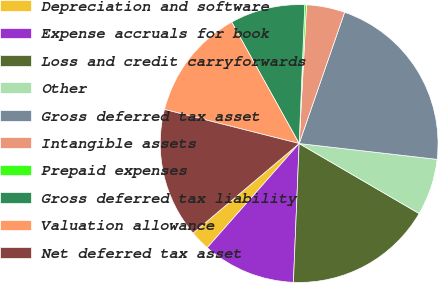Convert chart to OTSL. <chart><loc_0><loc_0><loc_500><loc_500><pie_chart><fcel>Depreciation and software<fcel>Expense accruals for book<fcel>Loss and credit carryforwards<fcel>Other<fcel>Gross deferred tax asset<fcel>Intangible assets<fcel>Prepaid expenses<fcel>Gross deferred tax liability<fcel>Valuation allowance<fcel>Net deferred tax asset<nl><fcel>2.33%<fcel>10.85%<fcel>17.25%<fcel>6.59%<fcel>21.51%<fcel>4.46%<fcel>0.2%<fcel>8.72%<fcel>12.98%<fcel>15.11%<nl></chart> 